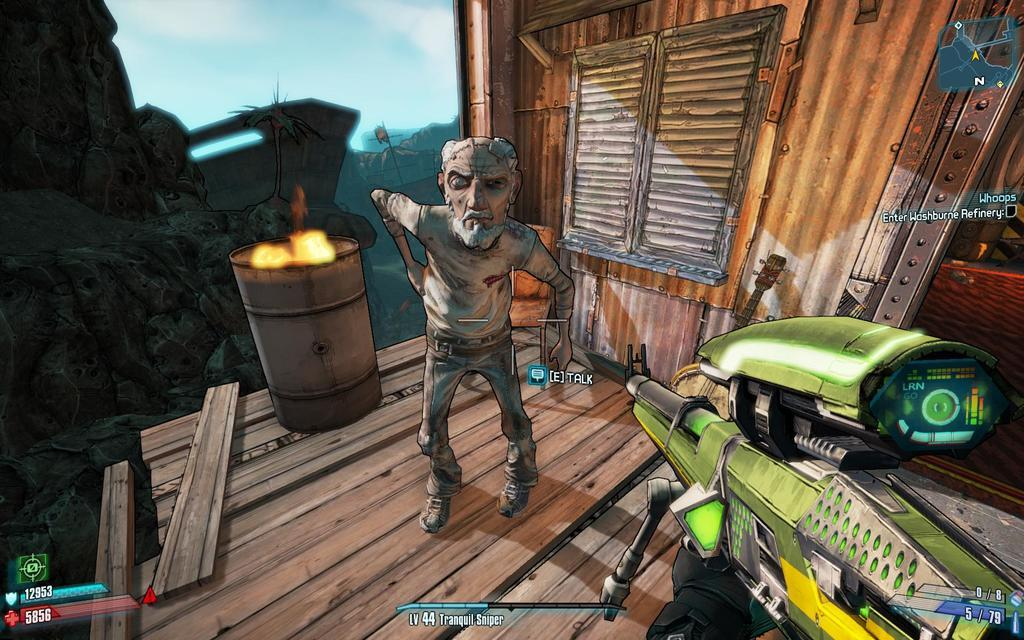What type of media is the image? The image is an animation. Can you describe the person in the image? There is a person in the image, but no specific details are provided. What object is present in the image alongside the person? There is a barrel in the image. What type of structure is visible in the image? There is a building with a window in the image. What word is written on the pencil in the image? There is no pencil present in the image, so it is not possible to answer that question. 